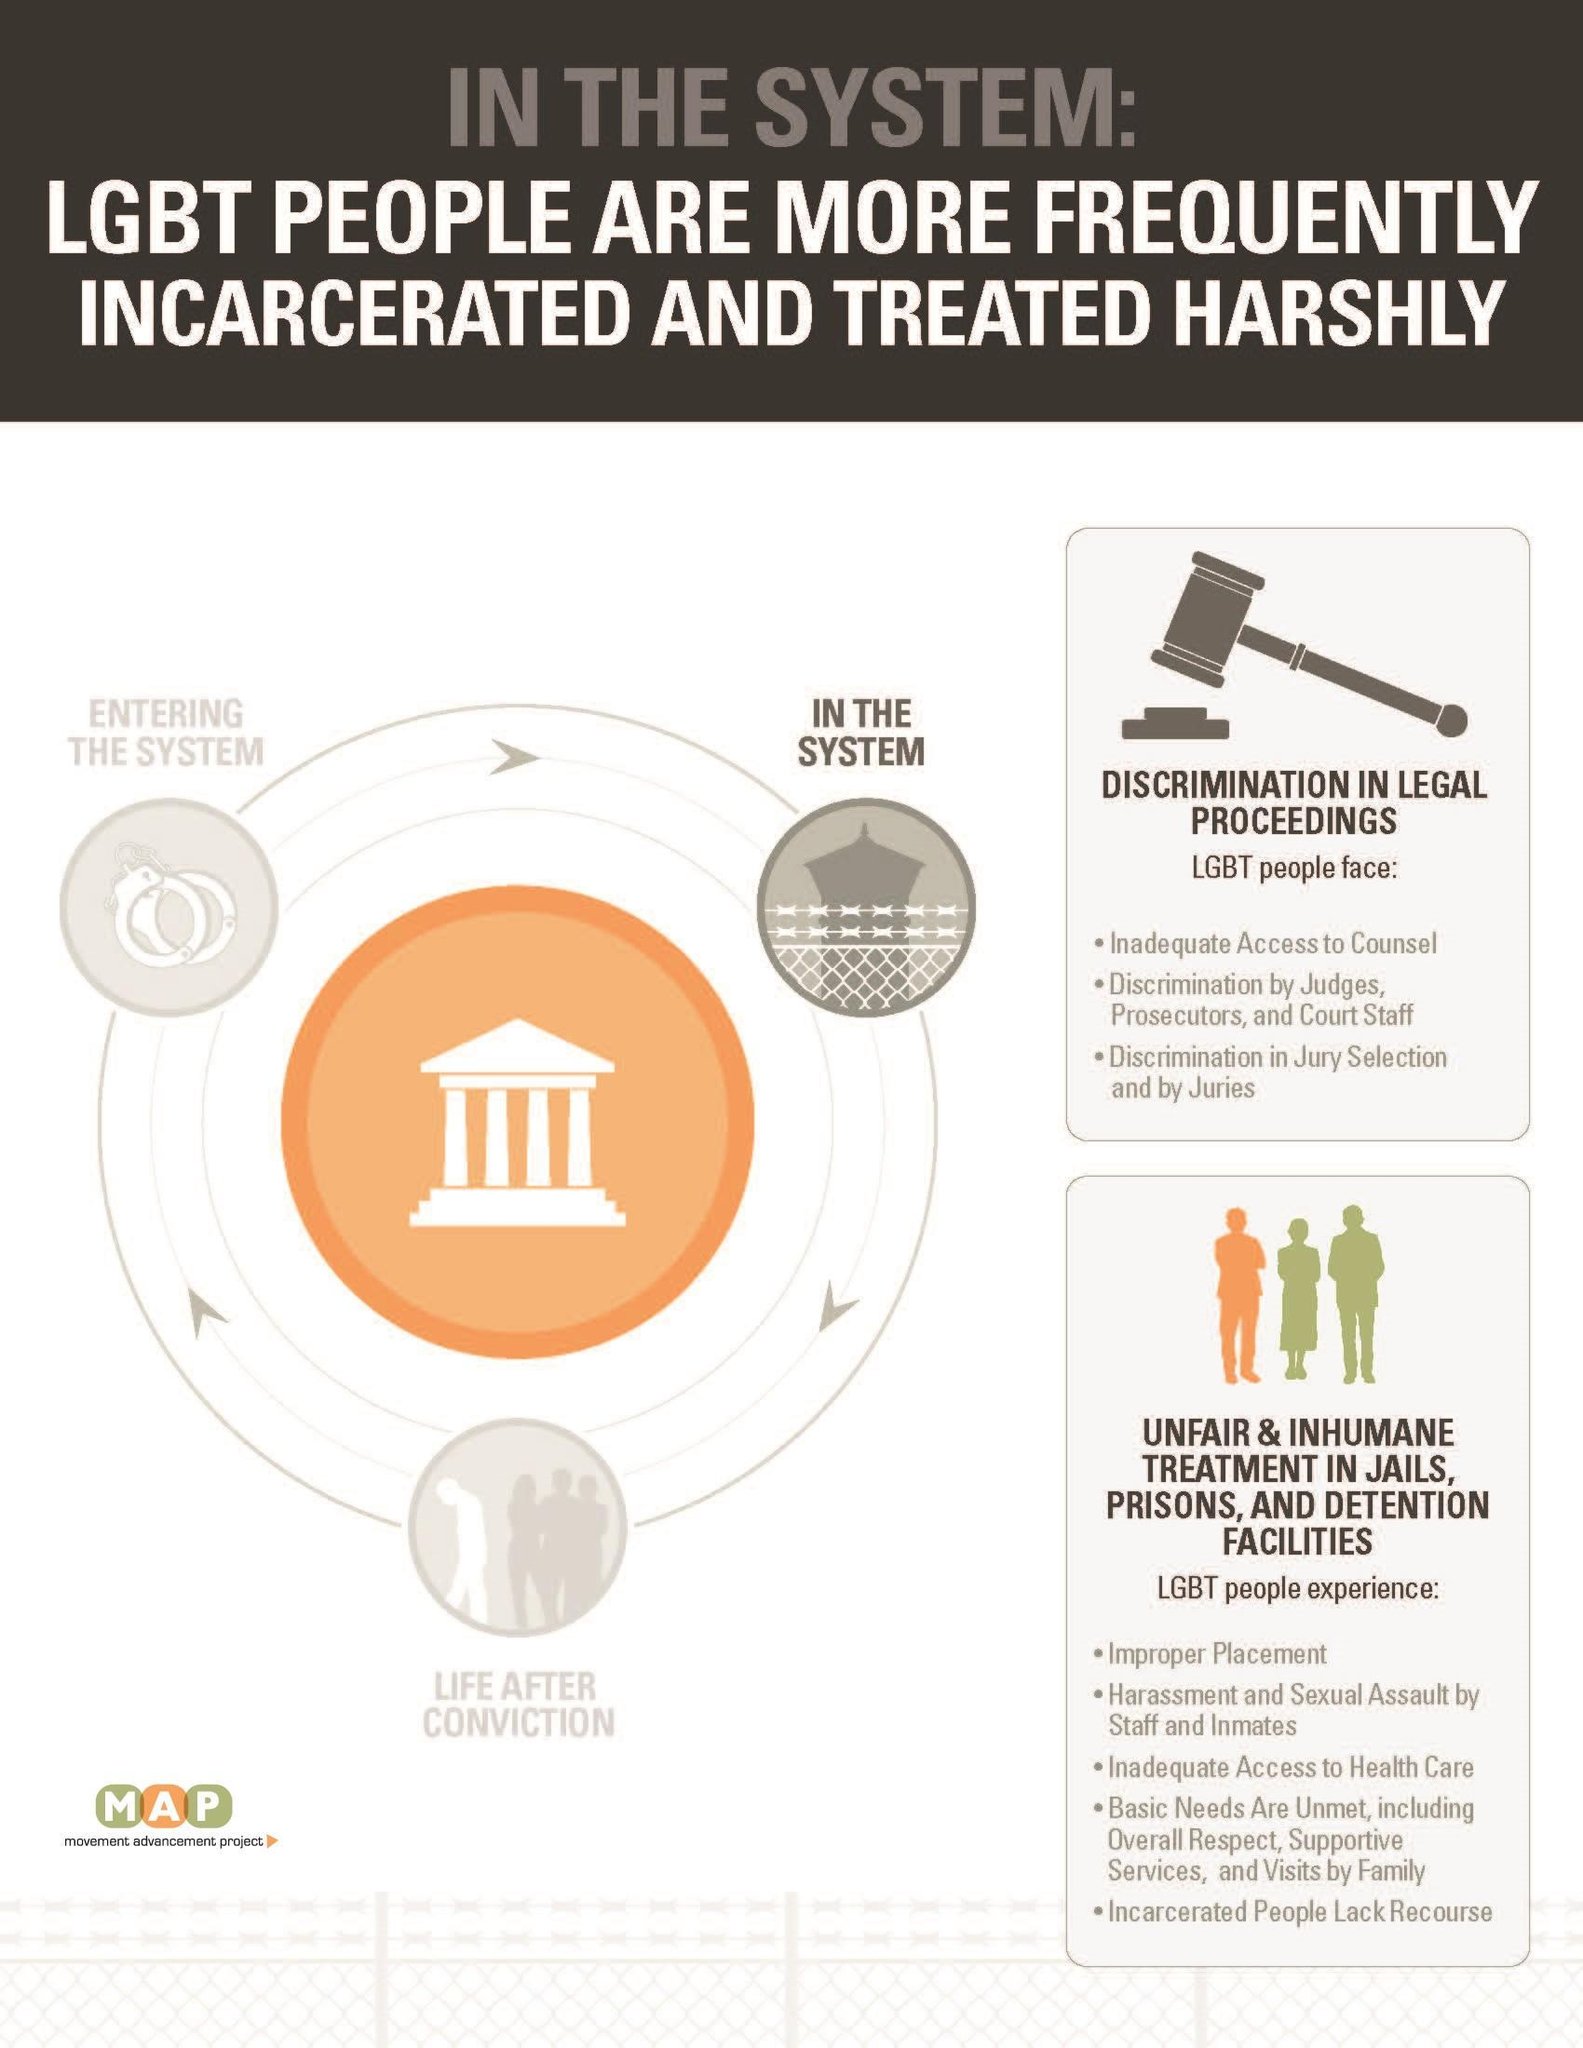Who face discrimination by Juries?
Answer the question with a short phrase. LGBT  people What is the first challenged faced by LGBT people in legal proceedings? inadequate access to counsel What is the third difficulty mentioned that is faced by LGBT people in prisons? inadequate access to health care What is the third challenged faced by LGBT people in legal proceedings? Discrimination in Jury Selection and by Juries Who face harassment and sexual assault by staff and inmates in prison? LGBT  people 